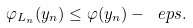Convert formula to latex. <formula><loc_0><loc_0><loc_500><loc_500>\varphi _ { L _ { n } } ( y _ { n } ) \leq \varphi ( y _ { n } ) - \ e p s .</formula> 